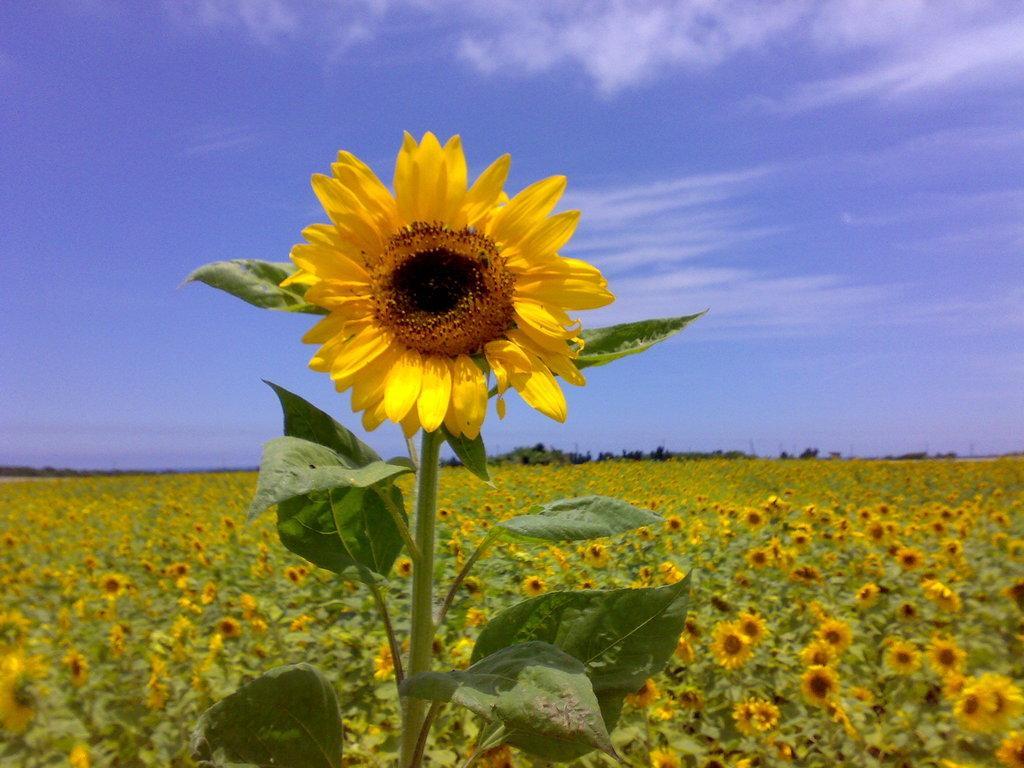Can you describe this image briefly? In this picture i can see sunflower plants. In the background i can see sky. 